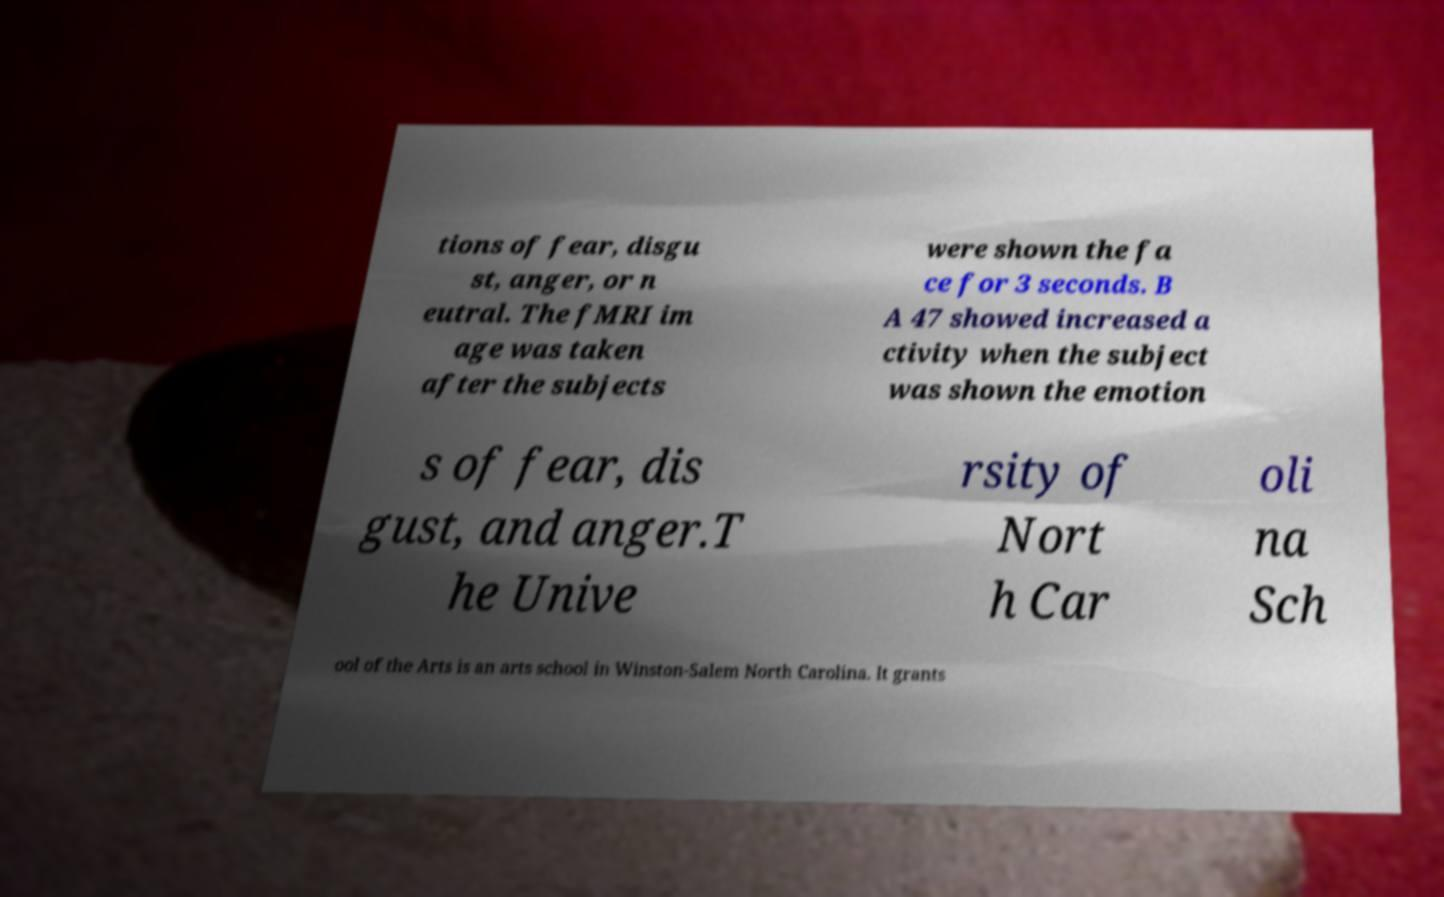I need the written content from this picture converted into text. Can you do that? tions of fear, disgu st, anger, or n eutral. The fMRI im age was taken after the subjects were shown the fa ce for 3 seconds. B A 47 showed increased a ctivity when the subject was shown the emotion s of fear, dis gust, and anger.T he Unive rsity of Nort h Car oli na Sch ool of the Arts is an arts school in Winston-Salem North Carolina. It grants 